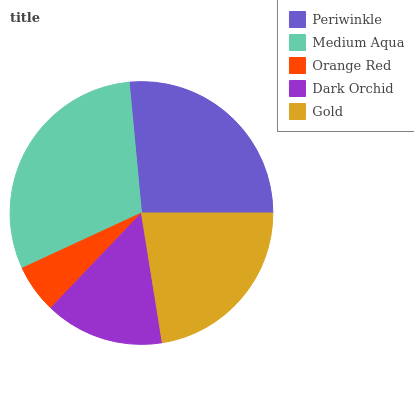Is Orange Red the minimum?
Answer yes or no. Yes. Is Medium Aqua the maximum?
Answer yes or no. Yes. Is Medium Aqua the minimum?
Answer yes or no. No. Is Orange Red the maximum?
Answer yes or no. No. Is Medium Aqua greater than Orange Red?
Answer yes or no. Yes. Is Orange Red less than Medium Aqua?
Answer yes or no. Yes. Is Orange Red greater than Medium Aqua?
Answer yes or no. No. Is Medium Aqua less than Orange Red?
Answer yes or no. No. Is Gold the high median?
Answer yes or no. Yes. Is Gold the low median?
Answer yes or no. Yes. Is Medium Aqua the high median?
Answer yes or no. No. Is Periwinkle the low median?
Answer yes or no. No. 